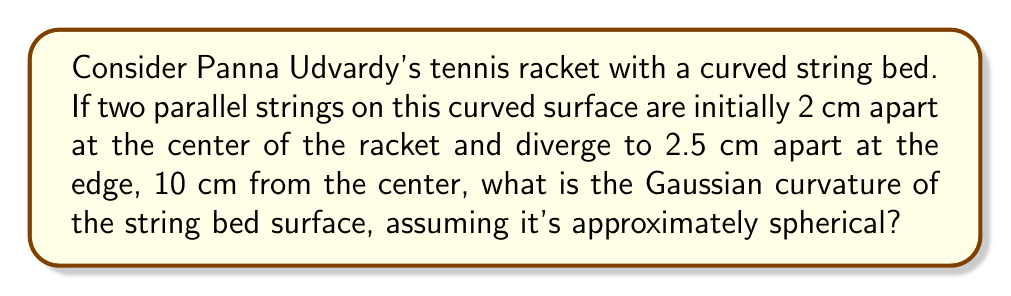Teach me how to tackle this problem. Let's approach this step-by-step:

1) In non-Euclidean geometry on a curved surface, parallel lines can diverge or converge. This divergence is related to the curvature of the surface.

2) For a spherical surface, we can use the formula for Gaussian curvature:

   $$K = \frac{1}{R^2}$$

   where $K$ is the Gaussian curvature and $R$ is the radius of the sphere.

3) To find $R$, we can use the formula for the arc length of a great circle on a sphere:

   $$s = R\theta$$

   where $s$ is the arc length and $\theta$ is the angle in radians.

4) In our case, $s = 10$ cm (distance from center to edge), and we need to find $\theta$.

5) We can find $\theta$ using the ratio of the string separation:

   $$\frac{2.5}{2} = \frac{\theta}{\sin\theta}$$

6) Solving this numerically (as it's transcendental), we get $\theta \approx 0.2618$ radians.

7) Now we can find $R$:

   $$R = \frac{s}{\theta} = \frac{10}{0.2618} \approx 38.20 \text{ cm}$$

8) Finally, we can calculate the Gaussian curvature:

   $$K = \frac{1}{R^2} = \frac{1}{38.20^2} \approx 0.000685 \text{ cm}^{-2}$$
Answer: $0.000685 \text{ cm}^{-2}$ 